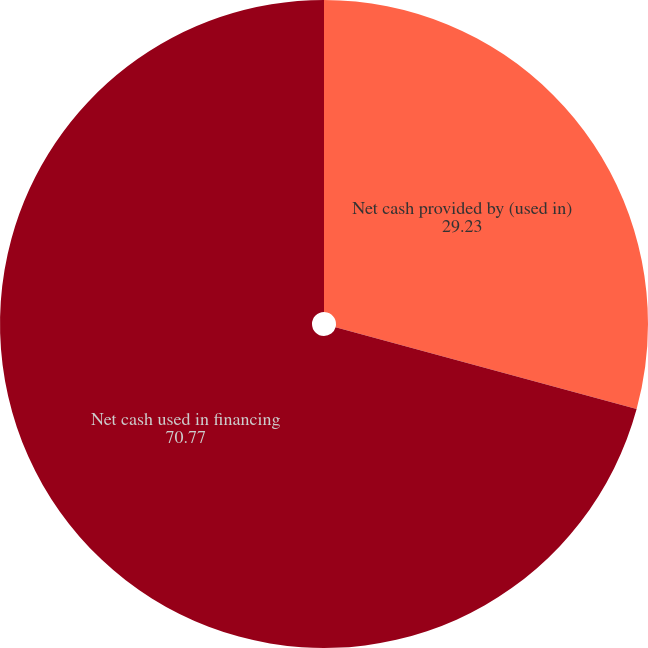Convert chart. <chart><loc_0><loc_0><loc_500><loc_500><pie_chart><fcel>Net cash provided by (used in)<fcel>Net cash used in financing<nl><fcel>29.23%<fcel>70.77%<nl></chart> 